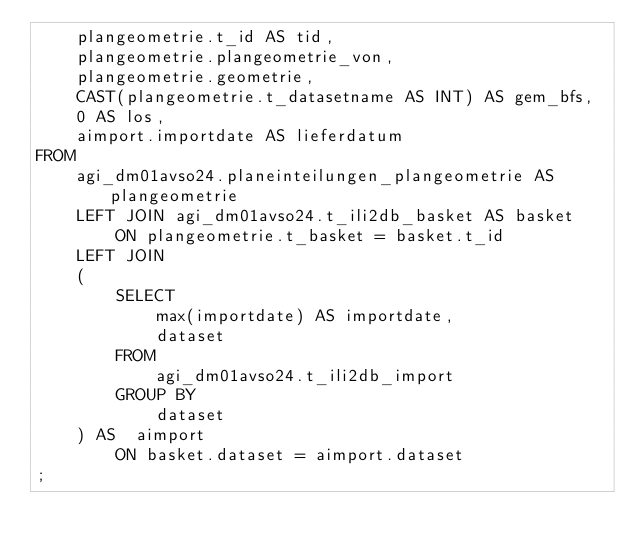Convert code to text. <code><loc_0><loc_0><loc_500><loc_500><_SQL_>    plangeometrie.t_id AS tid,
    plangeometrie.plangeometrie_von,
    plangeometrie.geometrie,
    CAST(plangeometrie.t_datasetname AS INT) AS gem_bfs,
    0 AS los,
    aimport.importdate AS lieferdatum
FROM
    agi_dm01avso24.planeinteilungen_plangeometrie AS plangeometrie
    LEFT JOIN agi_dm01avso24.t_ili2db_basket AS basket
        ON plangeometrie.t_basket = basket.t_id
    LEFT JOIN 
    (
        SELECT
            max(importdate) AS importdate,
            dataset
        FROM
            agi_dm01avso24.t_ili2db_import
        GROUP BY
            dataset 
    ) AS  aimport
        ON basket.dataset = aimport.dataset
;
</code> 